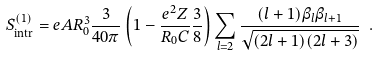<formula> <loc_0><loc_0><loc_500><loc_500>S ^ { ( 1 ) } _ { \text {intr} } = e A R _ { 0 } ^ { 3 } \frac { 3 } { 4 0 \pi } \left ( 1 - \frac { e ^ { 2 } Z } { R _ { 0 } C } \frac { 3 } { 8 } \right ) \sum _ { l = 2 } \frac { ( l + 1 ) \beta _ { l } \beta _ { l + 1 } } { \sqrt { ( 2 l + 1 ) ( 2 l + 3 ) } } \ .</formula> 